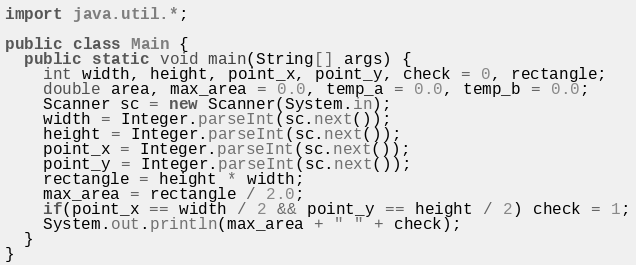Convert code to text. <code><loc_0><loc_0><loc_500><loc_500><_Java_>import java.util.*;

public class Main {
  public static void main(String[] args) {
    int width, height, point_x, point_y, check = 0, rectangle;
    double area, max_area = 0.0, temp_a = 0.0, temp_b = 0.0;
    Scanner sc = new Scanner(System.in);
    width = Integer.parseInt(sc.next());
    height = Integer.parseInt(sc.next());
    point_x = Integer.parseInt(sc.next());
    point_y = Integer.parseInt(sc.next());
    rectangle = height * width;
    max_area = rectangle / 2.0;
    if(point_x == width / 2 && point_y == height / 2) check = 1;
    System.out.println(max_area + " " + check);
  }
}
</code> 